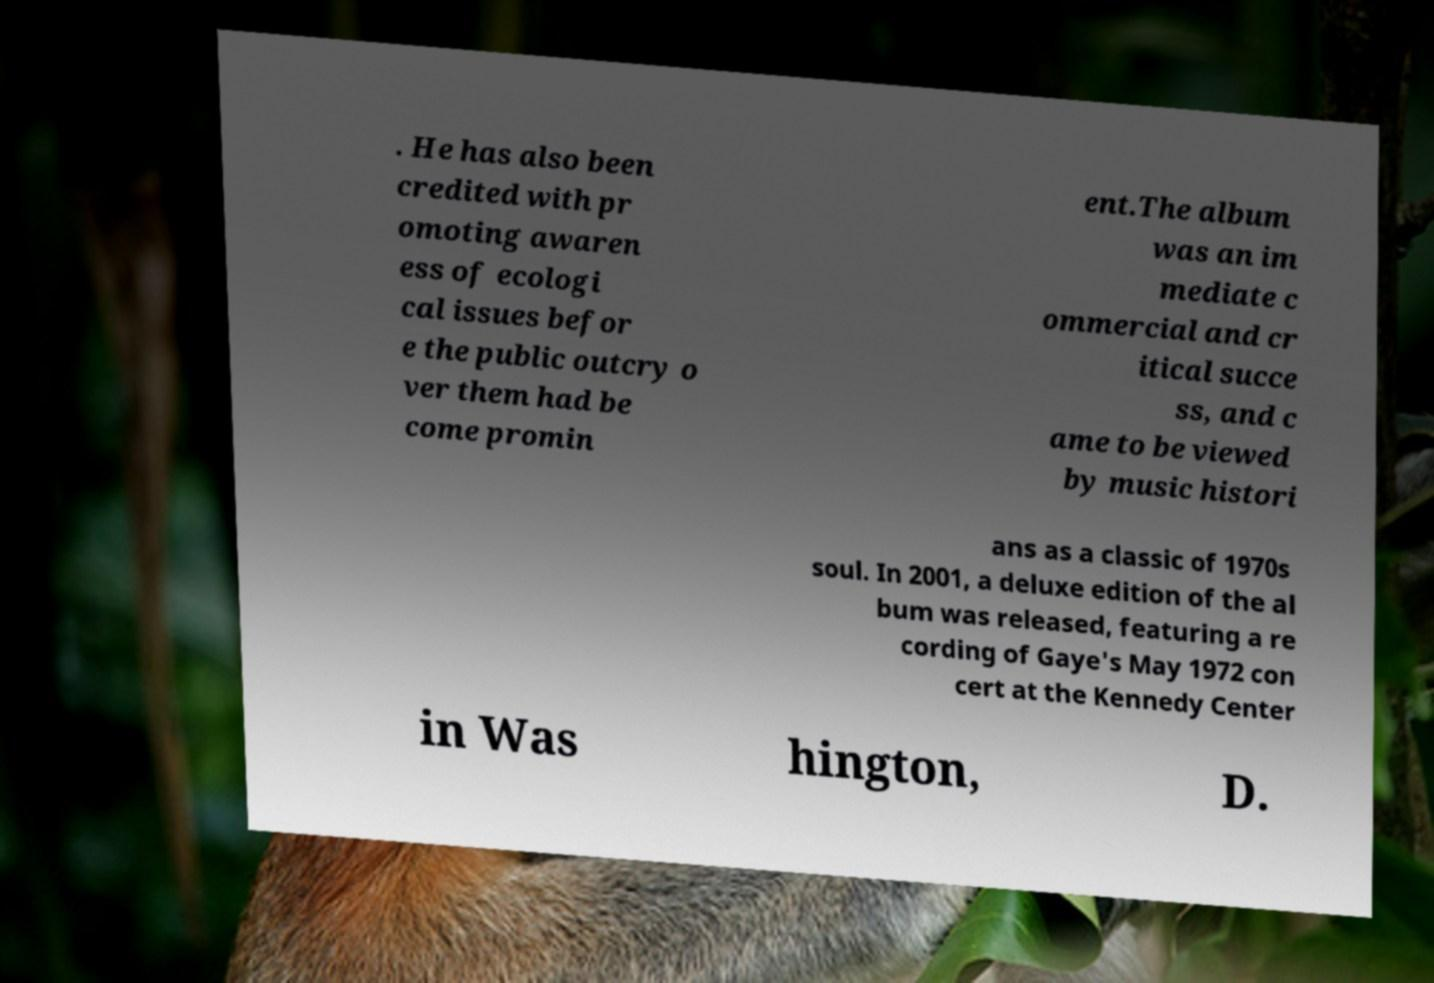Can you read and provide the text displayed in the image?This photo seems to have some interesting text. Can you extract and type it out for me? . He has also been credited with pr omoting awaren ess of ecologi cal issues befor e the public outcry o ver them had be come promin ent.The album was an im mediate c ommercial and cr itical succe ss, and c ame to be viewed by music histori ans as a classic of 1970s soul. In 2001, a deluxe edition of the al bum was released, featuring a re cording of Gaye's May 1972 con cert at the Kennedy Center in Was hington, D. 